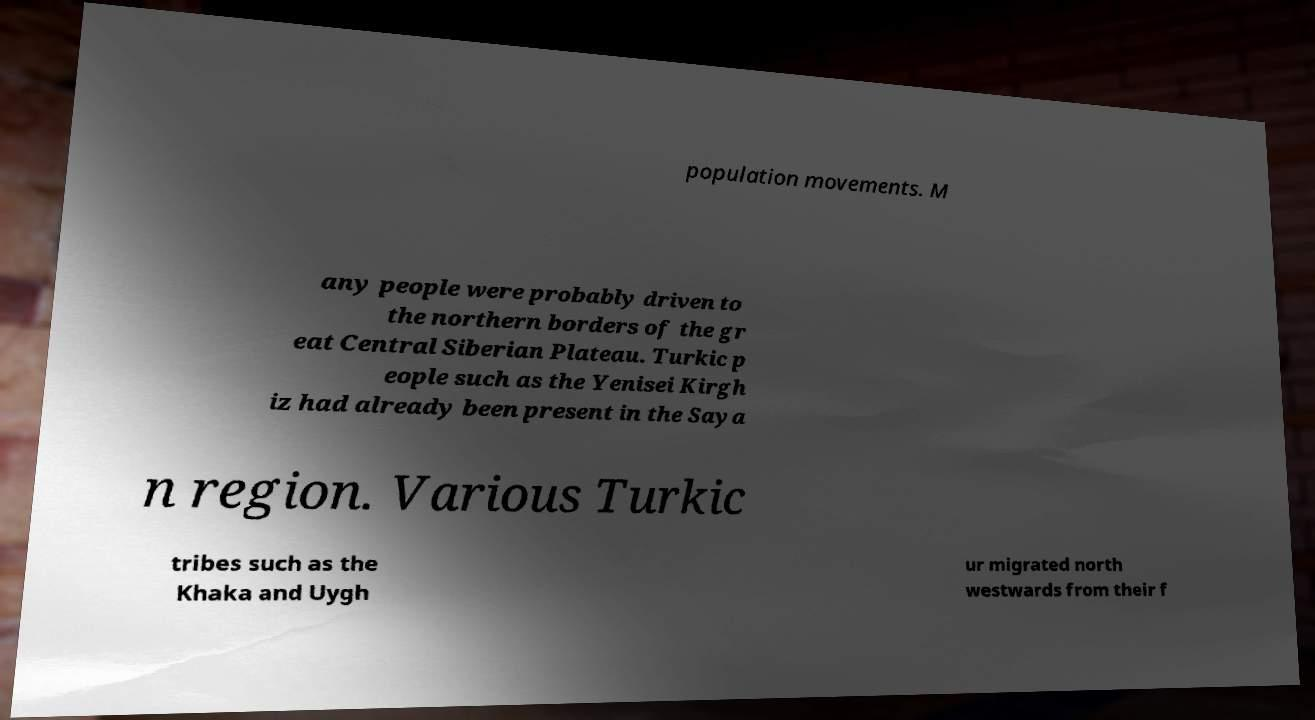For documentation purposes, I need the text within this image transcribed. Could you provide that? population movements. M any people were probably driven to the northern borders of the gr eat Central Siberian Plateau. Turkic p eople such as the Yenisei Kirgh iz had already been present in the Saya n region. Various Turkic tribes such as the Khaka and Uygh ur migrated north westwards from their f 